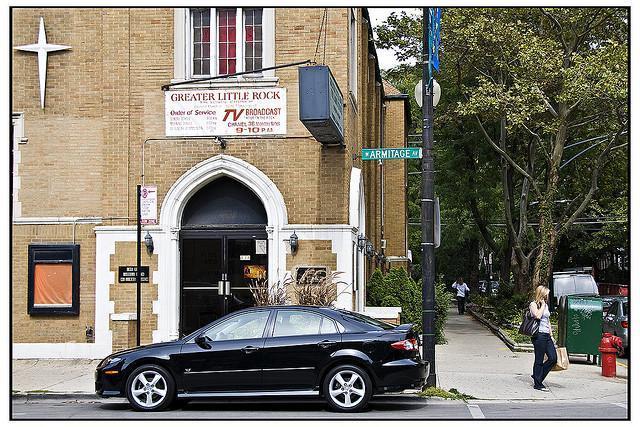How many bags is the lady carrying?
Give a very brief answer. 1. How many cars are there?
Give a very brief answer. 1. 